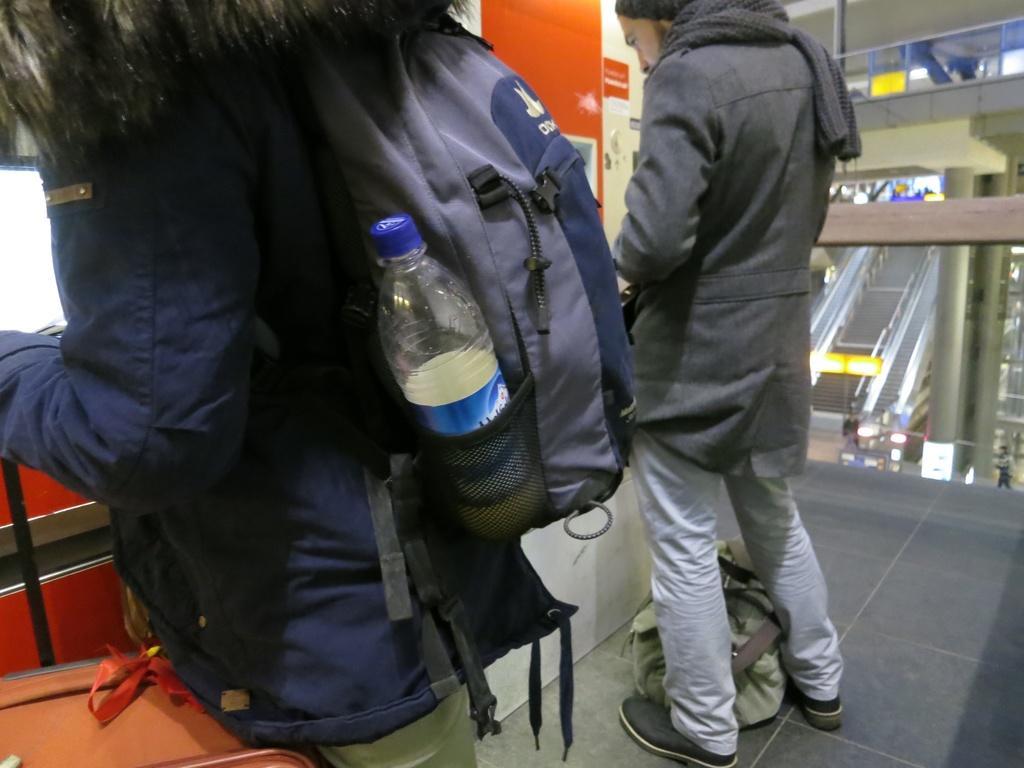Describe this image in one or two sentences. This picture is of inside. On the right corner we can see a person wearing a backpack and standing. In the center there is a man standing and there is a bag placed on the ground. In the background we can see the Elevators and a wall. 